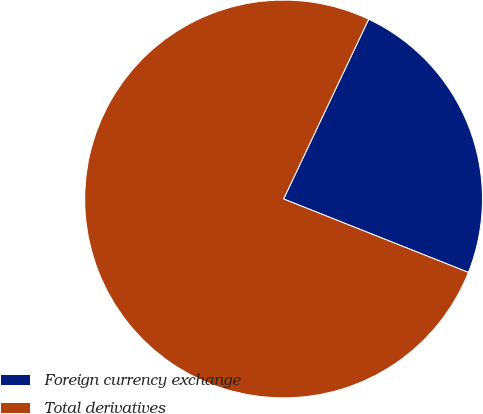Convert chart. <chart><loc_0><loc_0><loc_500><loc_500><pie_chart><fcel>Foreign currency exchange<fcel>Total derivatives<nl><fcel>23.98%<fcel>76.02%<nl></chart> 